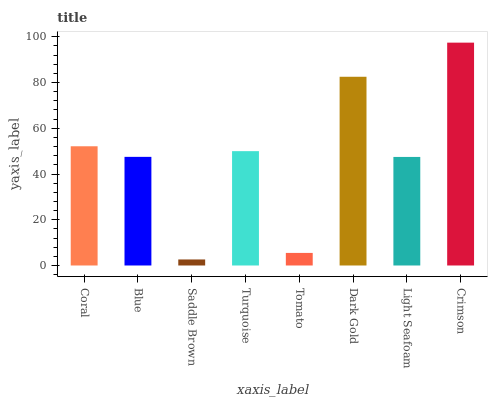Is Saddle Brown the minimum?
Answer yes or no. Yes. Is Crimson the maximum?
Answer yes or no. Yes. Is Blue the minimum?
Answer yes or no. No. Is Blue the maximum?
Answer yes or no. No. Is Coral greater than Blue?
Answer yes or no. Yes. Is Blue less than Coral?
Answer yes or no. Yes. Is Blue greater than Coral?
Answer yes or no. No. Is Coral less than Blue?
Answer yes or no. No. Is Turquoise the high median?
Answer yes or no. Yes. Is Blue the low median?
Answer yes or no. Yes. Is Light Seafoam the high median?
Answer yes or no. No. Is Tomato the low median?
Answer yes or no. No. 